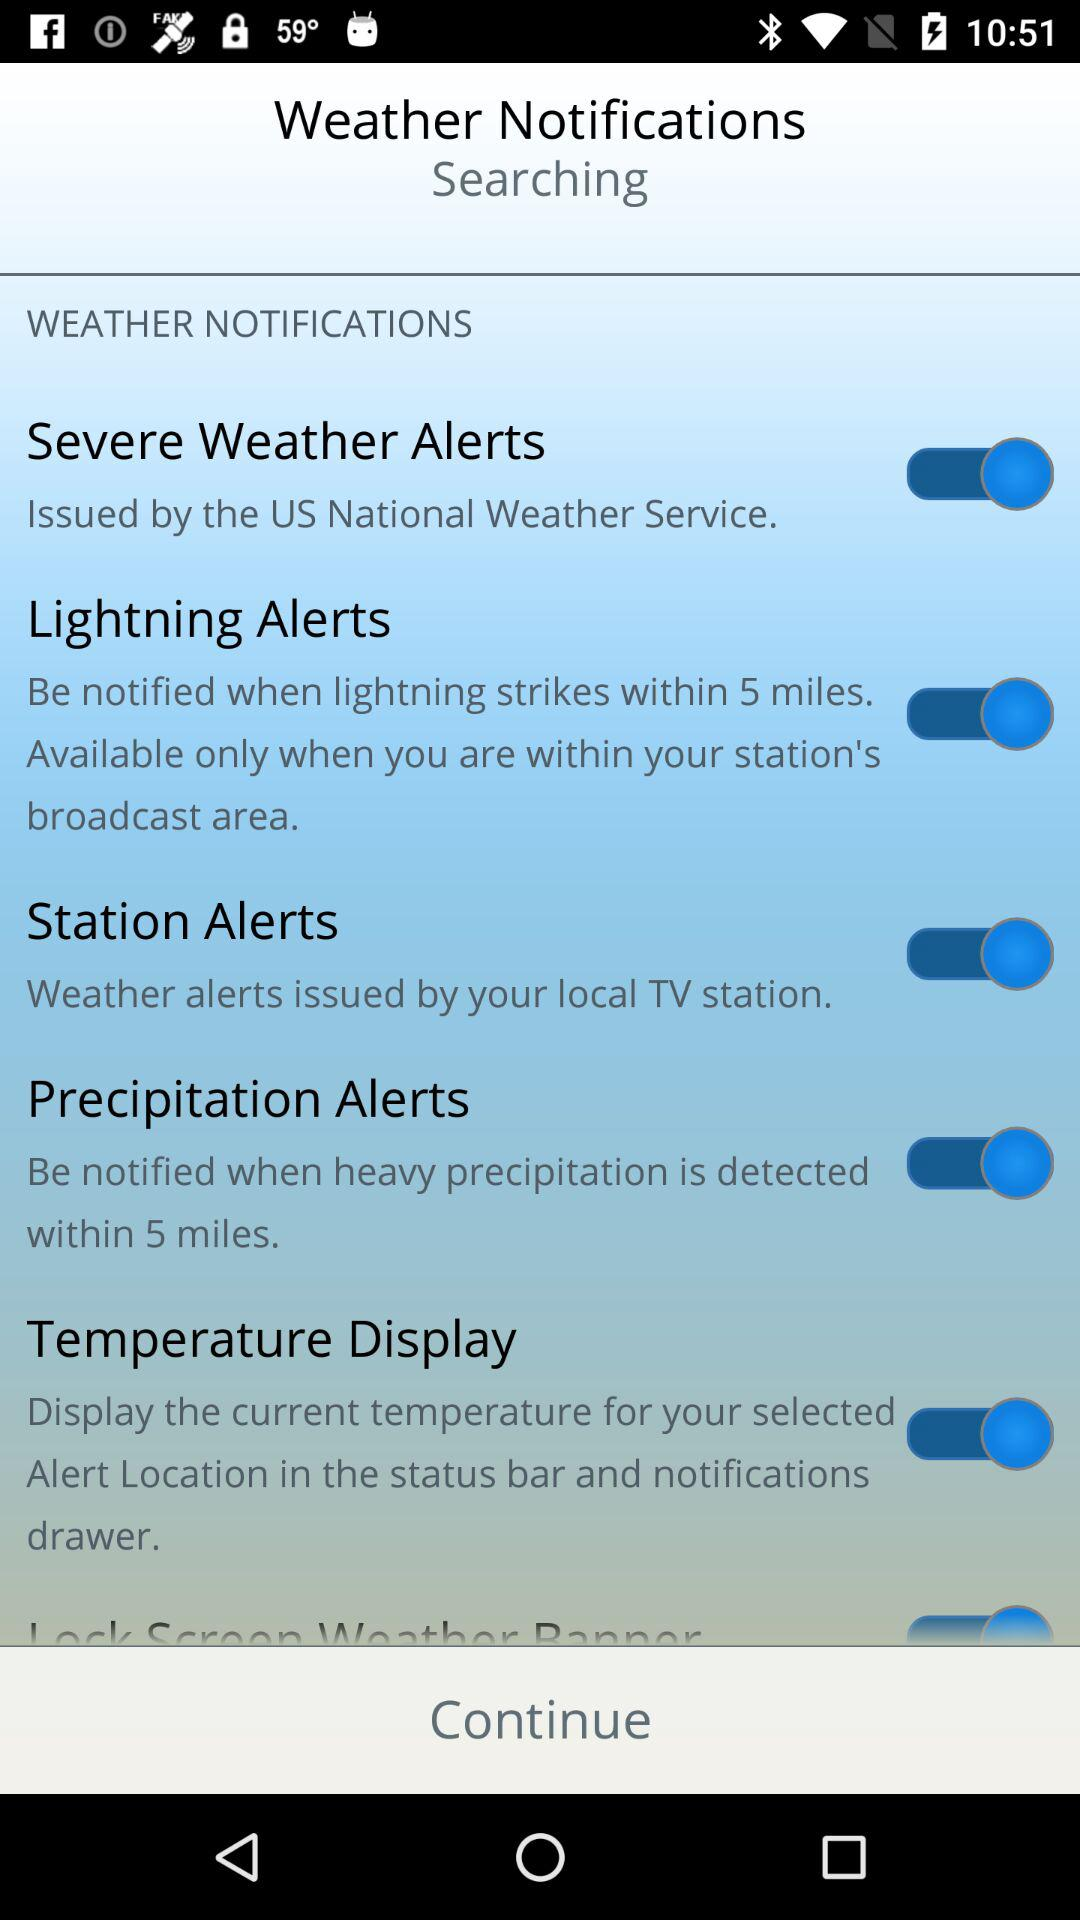From what distance Lightning alerts are generated?
When the provided information is insufficient, respond with <no answer>. <no answer> 